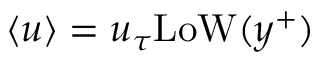<formula> <loc_0><loc_0><loc_500><loc_500>\left < u \right > = u _ { \tau } L o W ( y ^ { + } )</formula> 